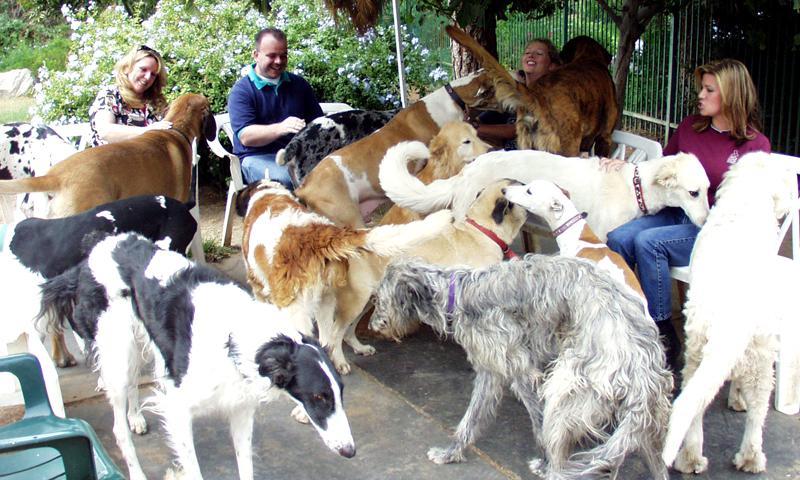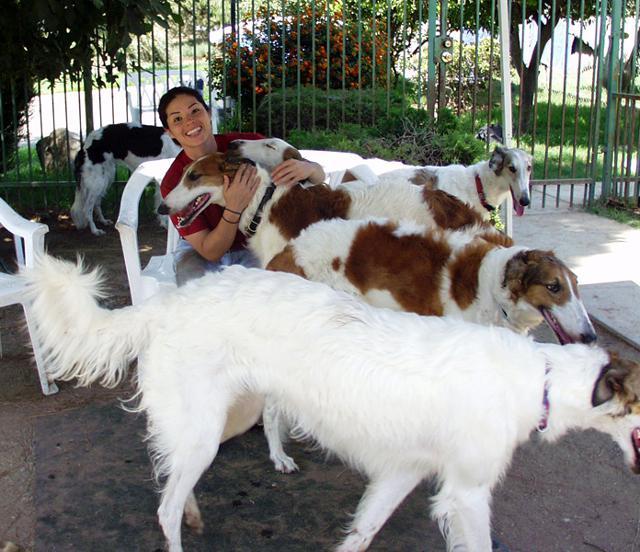The first image is the image on the left, the second image is the image on the right. For the images displayed, is the sentence "An image contains no more than two hound dogs." factually correct? Answer yes or no. No. 